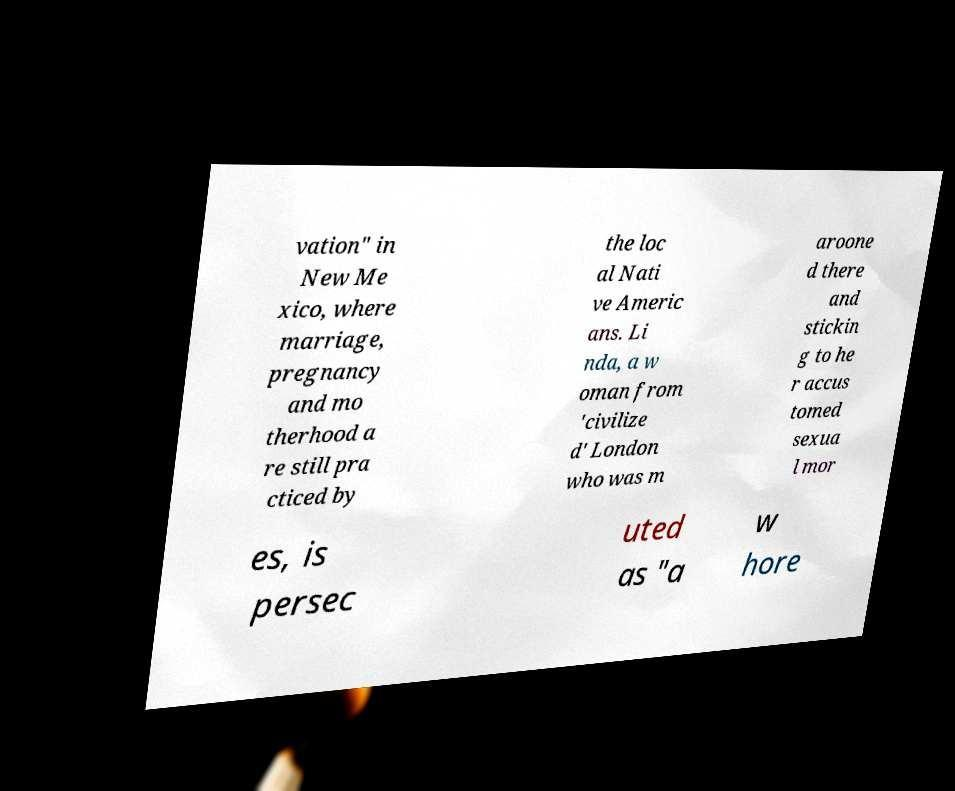Could you assist in decoding the text presented in this image and type it out clearly? vation" in New Me xico, where marriage, pregnancy and mo therhood a re still pra cticed by the loc al Nati ve Americ ans. Li nda, a w oman from 'civilize d' London who was m aroone d there and stickin g to he r accus tomed sexua l mor es, is persec uted as "a w hore 